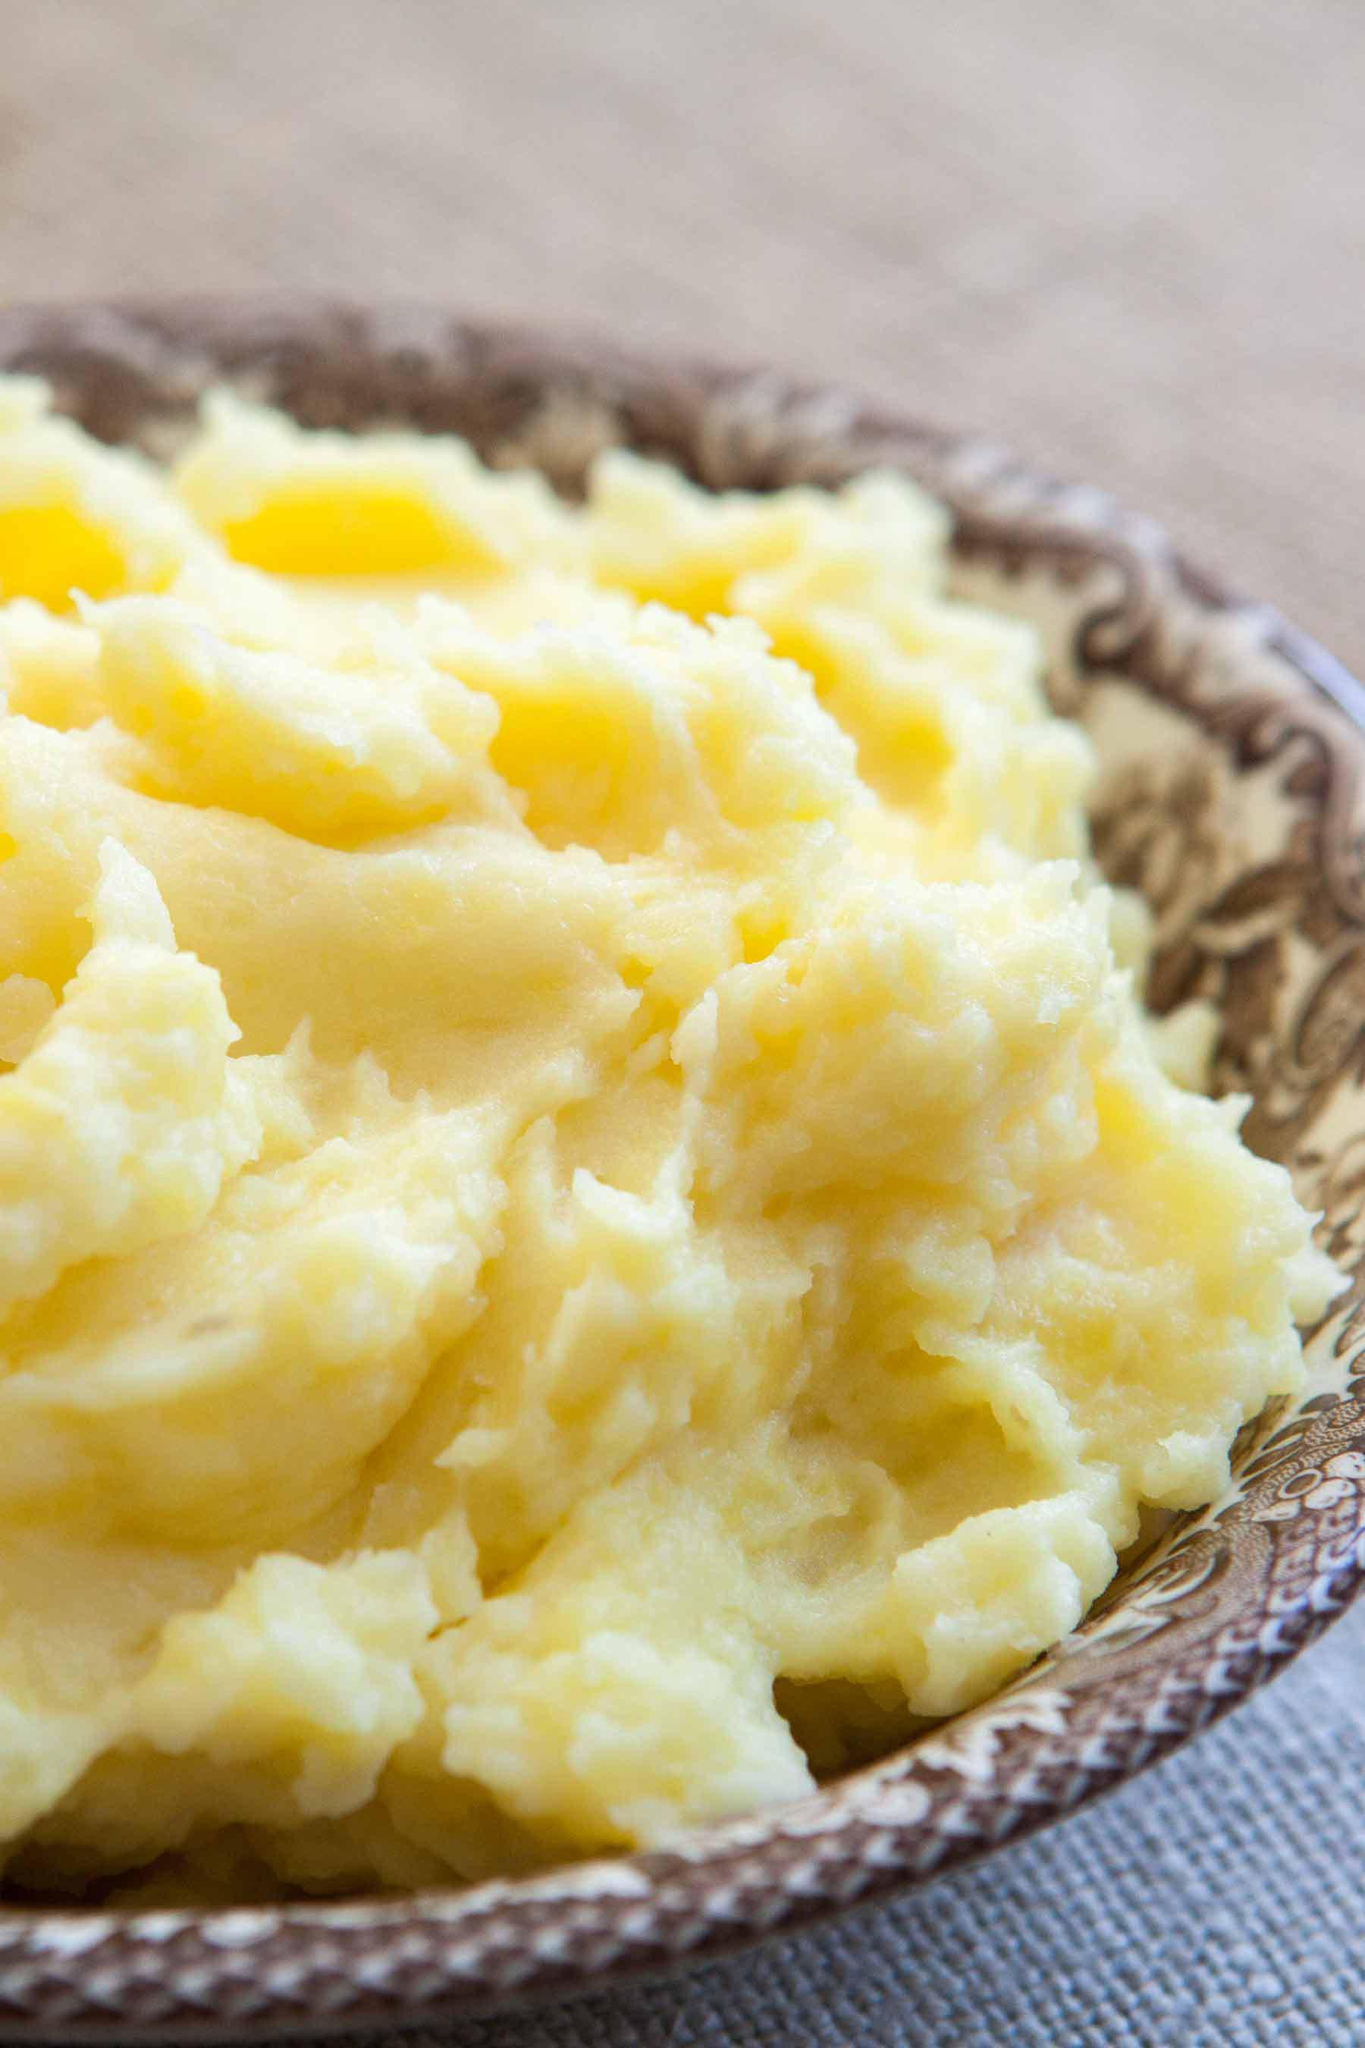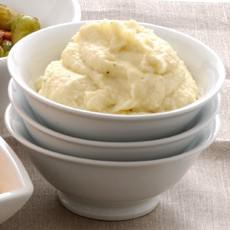The first image is the image on the left, the second image is the image on the right. Assess this claim about the two images: "A white bowl is holding the food in the image on the right.". Correct or not? Answer yes or no. Yes. The first image is the image on the left, the second image is the image on the right. Evaluate the accuracy of this statement regarding the images: "At least one image shows mashed potatoes in a round white bowl.". Is it true? Answer yes or no. Yes. 